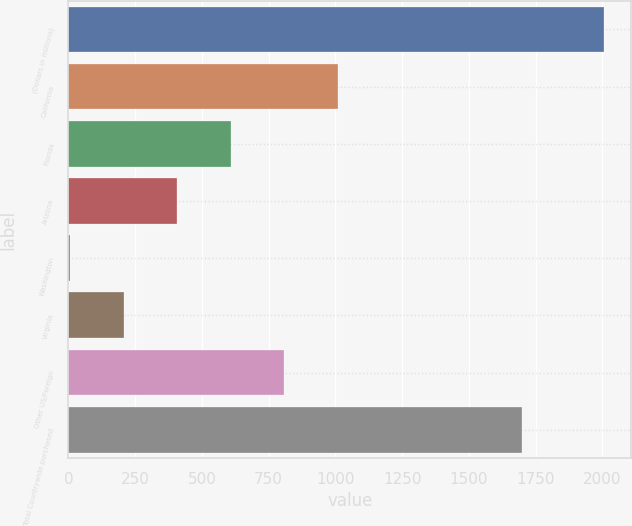Convert chart. <chart><loc_0><loc_0><loc_500><loc_500><bar_chart><fcel>(Dollars in millions)<fcel>California<fcel>Florida<fcel>Arizona<fcel>Washington<fcel>Virginia<fcel>Other US/Foreign<fcel>Total Countrywide purchased<nl><fcel>2008<fcel>1010<fcel>608<fcel>408<fcel>8<fcel>208<fcel>808<fcel>1699<nl></chart> 